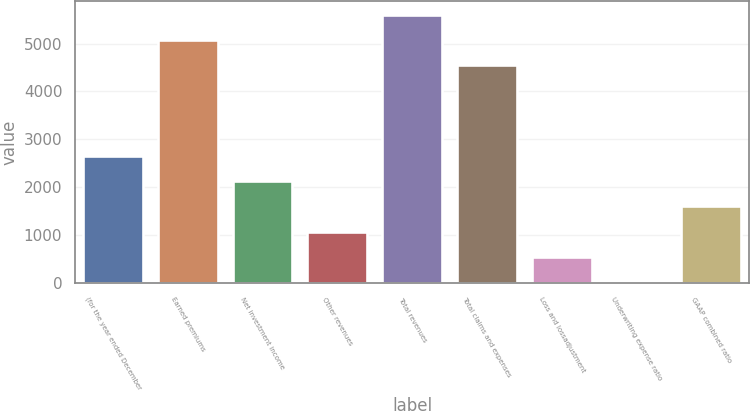<chart> <loc_0><loc_0><loc_500><loc_500><bar_chart><fcel>(for the year ended December<fcel>Earned premiums<fcel>Net investment income<fcel>Other revenues<fcel>Total revenues<fcel>Total claims and expenses<fcel>Loss and lossadjustment<fcel>Underwriting expense ratio<fcel>GAAP combined ratio<nl><fcel>2645.85<fcel>5079.43<fcel>2121.42<fcel>1072.56<fcel>5603.86<fcel>4555<fcel>548.13<fcel>23.7<fcel>1596.99<nl></chart> 